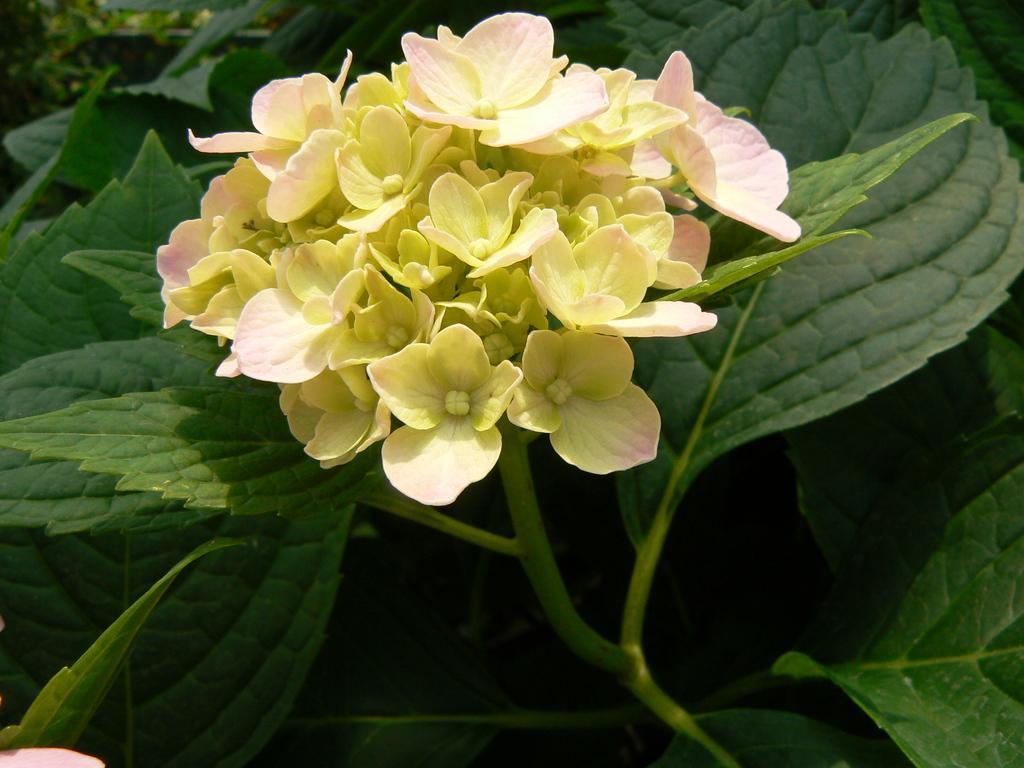Could you give a brief overview of what you see in this image? In this image there are bunch of small flowers in the middle. There are green leaves around it. 